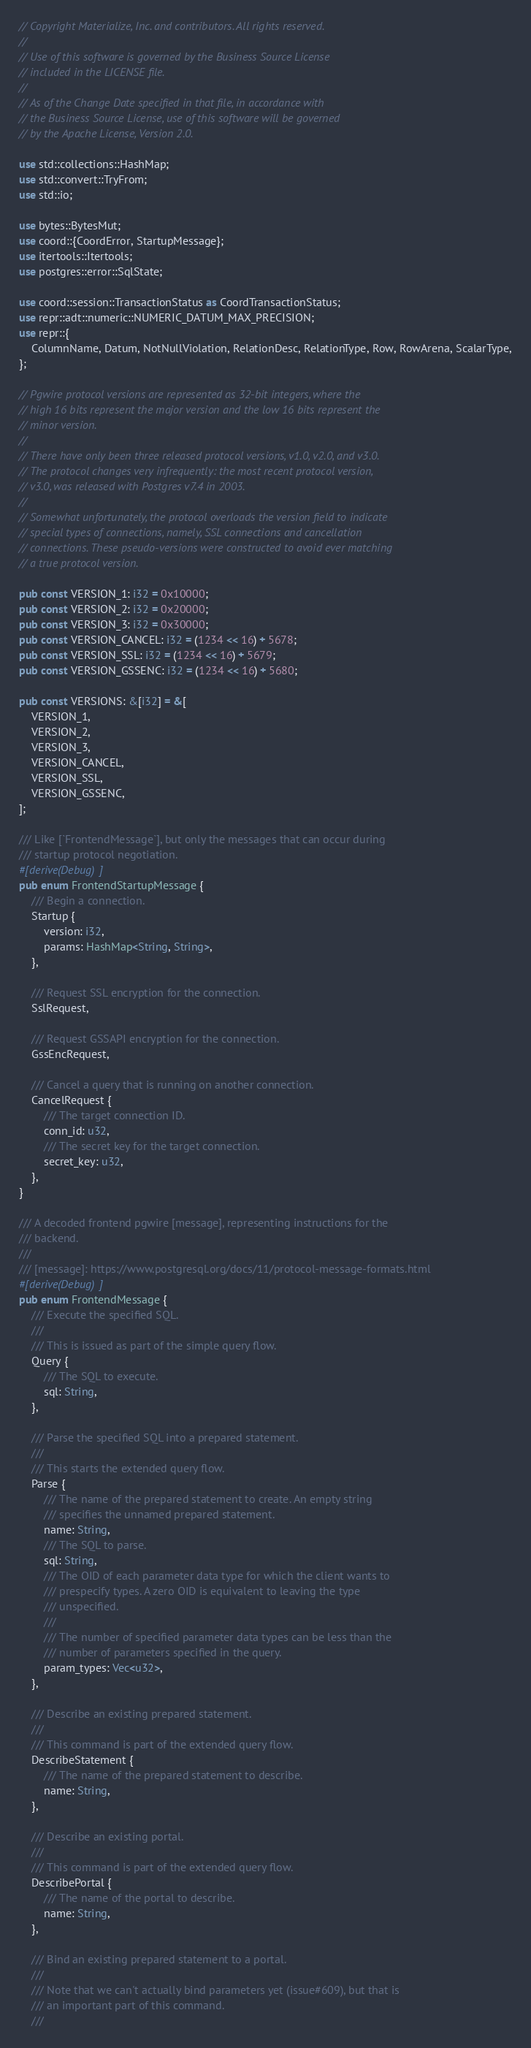Convert code to text. <code><loc_0><loc_0><loc_500><loc_500><_Rust_>// Copyright Materialize, Inc. and contributors. All rights reserved.
//
// Use of this software is governed by the Business Source License
// included in the LICENSE file.
//
// As of the Change Date specified in that file, in accordance with
// the Business Source License, use of this software will be governed
// by the Apache License, Version 2.0.

use std::collections::HashMap;
use std::convert::TryFrom;
use std::io;

use bytes::BytesMut;
use coord::{CoordError, StartupMessage};
use itertools::Itertools;
use postgres::error::SqlState;

use coord::session::TransactionStatus as CoordTransactionStatus;
use repr::adt::numeric::NUMERIC_DATUM_MAX_PRECISION;
use repr::{
    ColumnName, Datum, NotNullViolation, RelationDesc, RelationType, Row, RowArena, ScalarType,
};

// Pgwire protocol versions are represented as 32-bit integers, where the
// high 16 bits represent the major version and the low 16 bits represent the
// minor version.
//
// There have only been three released protocol versions, v1.0, v2.0, and v3.0.
// The protocol changes very infrequently: the most recent protocol version,
// v3.0, was released with Postgres v7.4 in 2003.
//
// Somewhat unfortunately, the protocol overloads the version field to indicate
// special types of connections, namely, SSL connections and cancellation
// connections. These pseudo-versions were constructed to avoid ever matching
// a true protocol version.

pub const VERSION_1: i32 = 0x10000;
pub const VERSION_2: i32 = 0x20000;
pub const VERSION_3: i32 = 0x30000;
pub const VERSION_CANCEL: i32 = (1234 << 16) + 5678;
pub const VERSION_SSL: i32 = (1234 << 16) + 5679;
pub const VERSION_GSSENC: i32 = (1234 << 16) + 5680;

pub const VERSIONS: &[i32] = &[
    VERSION_1,
    VERSION_2,
    VERSION_3,
    VERSION_CANCEL,
    VERSION_SSL,
    VERSION_GSSENC,
];

/// Like [`FrontendMessage`], but only the messages that can occur during
/// startup protocol negotiation.
#[derive(Debug)]
pub enum FrontendStartupMessage {
    /// Begin a connection.
    Startup {
        version: i32,
        params: HashMap<String, String>,
    },

    /// Request SSL encryption for the connection.
    SslRequest,

    /// Request GSSAPI encryption for the connection.
    GssEncRequest,

    /// Cancel a query that is running on another connection.
    CancelRequest {
        /// The target connection ID.
        conn_id: u32,
        /// The secret key for the target connection.
        secret_key: u32,
    },
}

/// A decoded frontend pgwire [message], representing instructions for the
/// backend.
///
/// [message]: https://www.postgresql.org/docs/11/protocol-message-formats.html
#[derive(Debug)]
pub enum FrontendMessage {
    /// Execute the specified SQL.
    ///
    /// This is issued as part of the simple query flow.
    Query {
        /// The SQL to execute.
        sql: String,
    },

    /// Parse the specified SQL into a prepared statement.
    ///
    /// This starts the extended query flow.
    Parse {
        /// The name of the prepared statement to create. An empty string
        /// specifies the unnamed prepared statement.
        name: String,
        /// The SQL to parse.
        sql: String,
        /// The OID of each parameter data type for which the client wants to
        /// prespecify types. A zero OID is equivalent to leaving the type
        /// unspecified.
        ///
        /// The number of specified parameter data types can be less than the
        /// number of parameters specified in the query.
        param_types: Vec<u32>,
    },

    /// Describe an existing prepared statement.
    ///
    /// This command is part of the extended query flow.
    DescribeStatement {
        /// The name of the prepared statement to describe.
        name: String,
    },

    /// Describe an existing portal.
    ///
    /// This command is part of the extended query flow.
    DescribePortal {
        /// The name of the portal to describe.
        name: String,
    },

    /// Bind an existing prepared statement to a portal.
    ///
    /// Note that we can't actually bind parameters yet (issue#609), but that is
    /// an important part of this command.
    ///</code> 